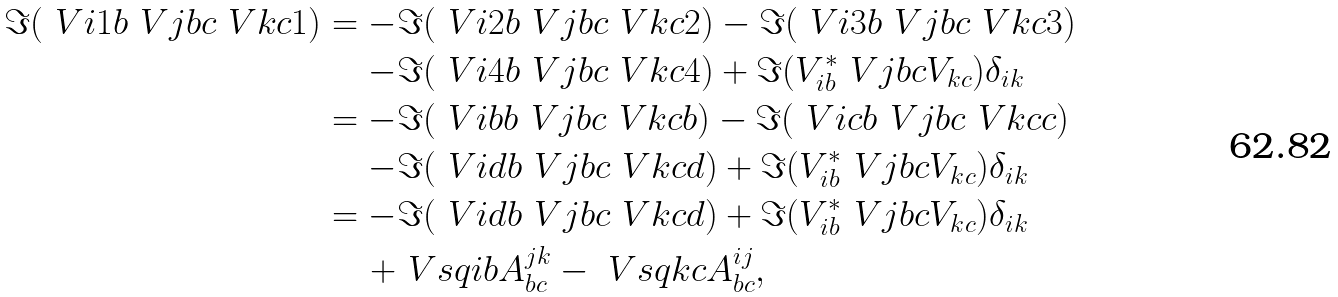Convert formula to latex. <formula><loc_0><loc_0><loc_500><loc_500>\Im ( \ V { i } { 1 } { b } \ V { j } { b } { c } \ V { k } { c } { 1 } ) = - & \Im ( \ V { i } { 2 } { b } \ V { j } { b } { c } \ V { k } { c } { 2 } ) - \Im ( \ V { i } { 3 } { b } \ V { j } { b } { c } \ V { k } { c } { 3 } ) \\ - & \Im ( \ V { i } { 4 } { b } \ V { j } { b } { c } \ V { k } { c } { 4 } ) + \Im ( V _ { i b } ^ { * } \ V { j } { b } { c } V _ { k c } ) \delta _ { i k } \\ = - & \Im ( \ V { i } { b } { b } \ V { j } { b } { c } \ V { k } { c } { b } ) - \Im ( \ V { i } { c } { b } \ V { j } { b } { c } \ V { k } { c } { c } ) \\ - & \Im ( \ V { i } { d } { b } \ V { j } { b } { c } \ V { k } { c } { d } ) + \Im ( V _ { i b } ^ { * } \ V { j } { b } { c } V _ { k c } ) \delta _ { i k } \\ = - & \Im ( \ V { i } { d } { b } \ V { j } { b } { c } \ V { k } { c } { d } ) + \Im ( V _ { i b } ^ { * } \ V { j } { b } { c } V _ { k c } ) \delta _ { i k } \\ + & \ V s q { i b } A ^ { j k } _ { b c } - \ V s q { k c } A ^ { i j } _ { b c } ,</formula> 